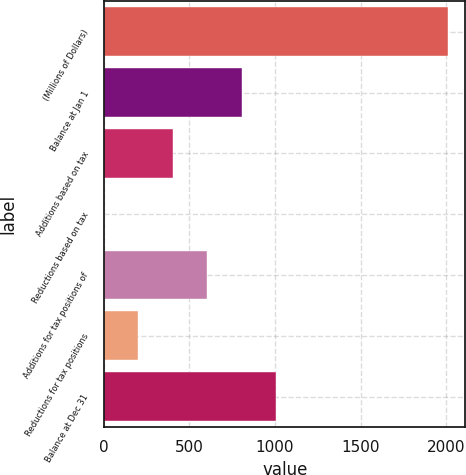Convert chart. <chart><loc_0><loc_0><loc_500><loc_500><bar_chart><fcel>(Millions of Dollars)<fcel>Balance at Jan 1<fcel>Additions based on tax<fcel>Reductions based on tax<fcel>Additions for tax positions of<fcel>Reductions for tax positions<fcel>Balance at Dec 31<nl><fcel>2013<fcel>805.44<fcel>402.92<fcel>0.4<fcel>604.18<fcel>201.66<fcel>1006.7<nl></chart> 